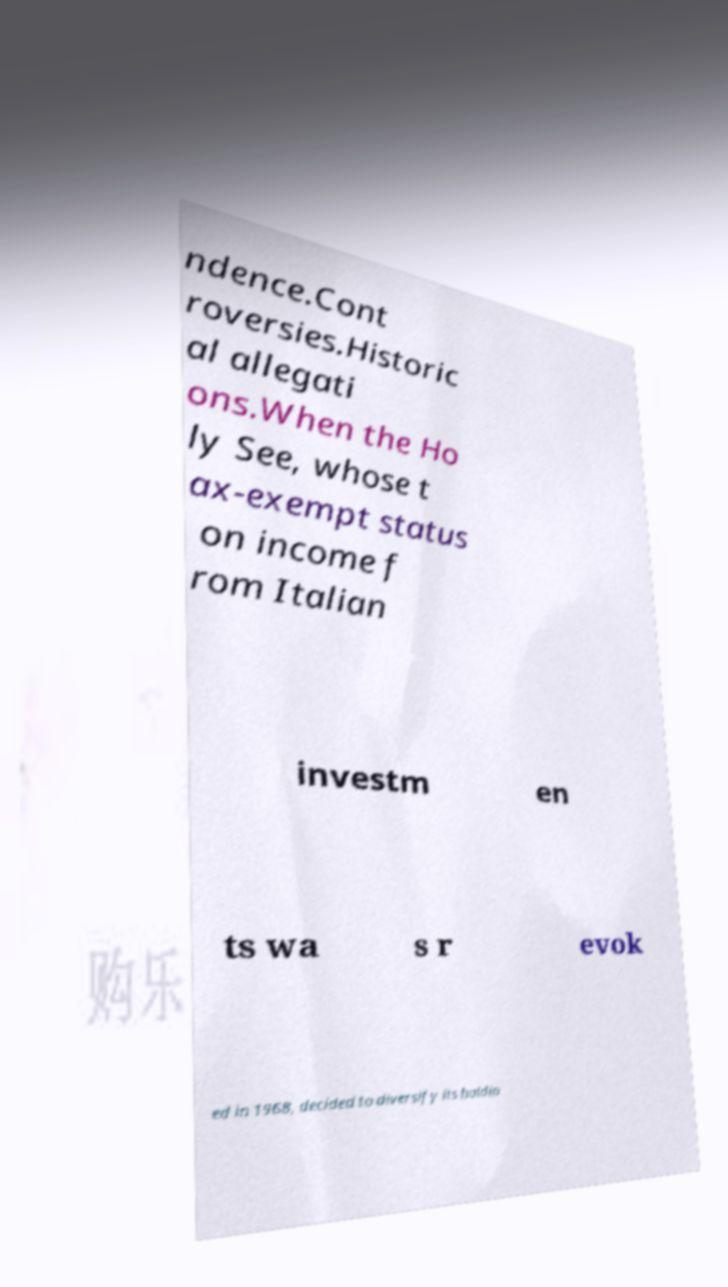For documentation purposes, I need the text within this image transcribed. Could you provide that? ndence.Cont roversies.Historic al allegati ons.When the Ho ly See, whose t ax-exempt status on income f rom Italian investm en ts wa s r evok ed in 1968, decided to diversify its holdin 